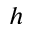<formula> <loc_0><loc_0><loc_500><loc_500>h</formula> 